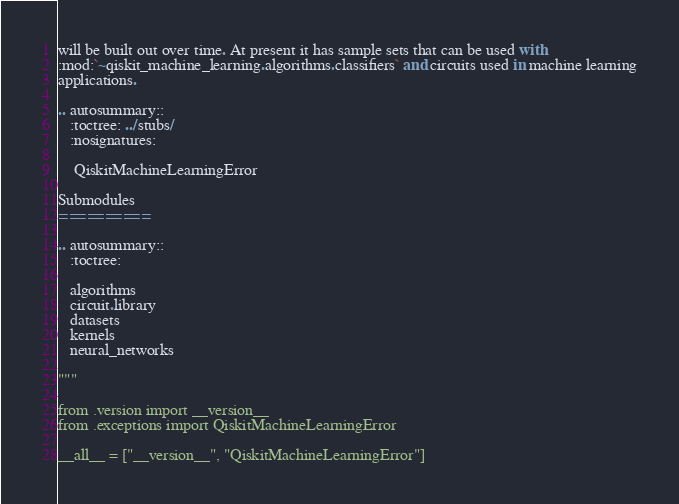<code> <loc_0><loc_0><loc_500><loc_500><_Python_>will be built out over time. At present it has sample sets that can be used with
:mod:`~qiskit_machine_learning.algorithms.classifiers` and circuits used in machine learning
applications.

.. autosummary::
   :toctree: ../stubs/
   :nosignatures:

    QiskitMachineLearningError

Submodules
==========

.. autosummary::
   :toctree:

   algorithms
   circuit.library
   datasets
   kernels
   neural_networks

"""

from .version import __version__
from .exceptions import QiskitMachineLearningError

__all__ = ["__version__", "QiskitMachineLearningError"]
</code> 